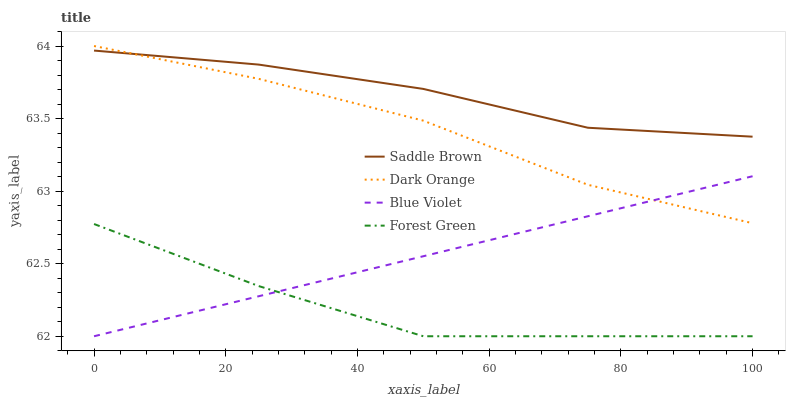Does Forest Green have the minimum area under the curve?
Answer yes or no. Yes. Does Saddle Brown have the maximum area under the curve?
Answer yes or no. Yes. Does Saddle Brown have the minimum area under the curve?
Answer yes or no. No. Does Forest Green have the maximum area under the curve?
Answer yes or no. No. Is Blue Violet the smoothest?
Answer yes or no. Yes. Is Forest Green the roughest?
Answer yes or no. Yes. Is Saddle Brown the smoothest?
Answer yes or no. No. Is Saddle Brown the roughest?
Answer yes or no. No. Does Forest Green have the lowest value?
Answer yes or no. Yes. Does Saddle Brown have the lowest value?
Answer yes or no. No. Does Dark Orange have the highest value?
Answer yes or no. Yes. Does Saddle Brown have the highest value?
Answer yes or no. No. Is Forest Green less than Saddle Brown?
Answer yes or no. Yes. Is Dark Orange greater than Forest Green?
Answer yes or no. Yes. Does Blue Violet intersect Forest Green?
Answer yes or no. Yes. Is Blue Violet less than Forest Green?
Answer yes or no. No. Is Blue Violet greater than Forest Green?
Answer yes or no. No. Does Forest Green intersect Saddle Brown?
Answer yes or no. No. 